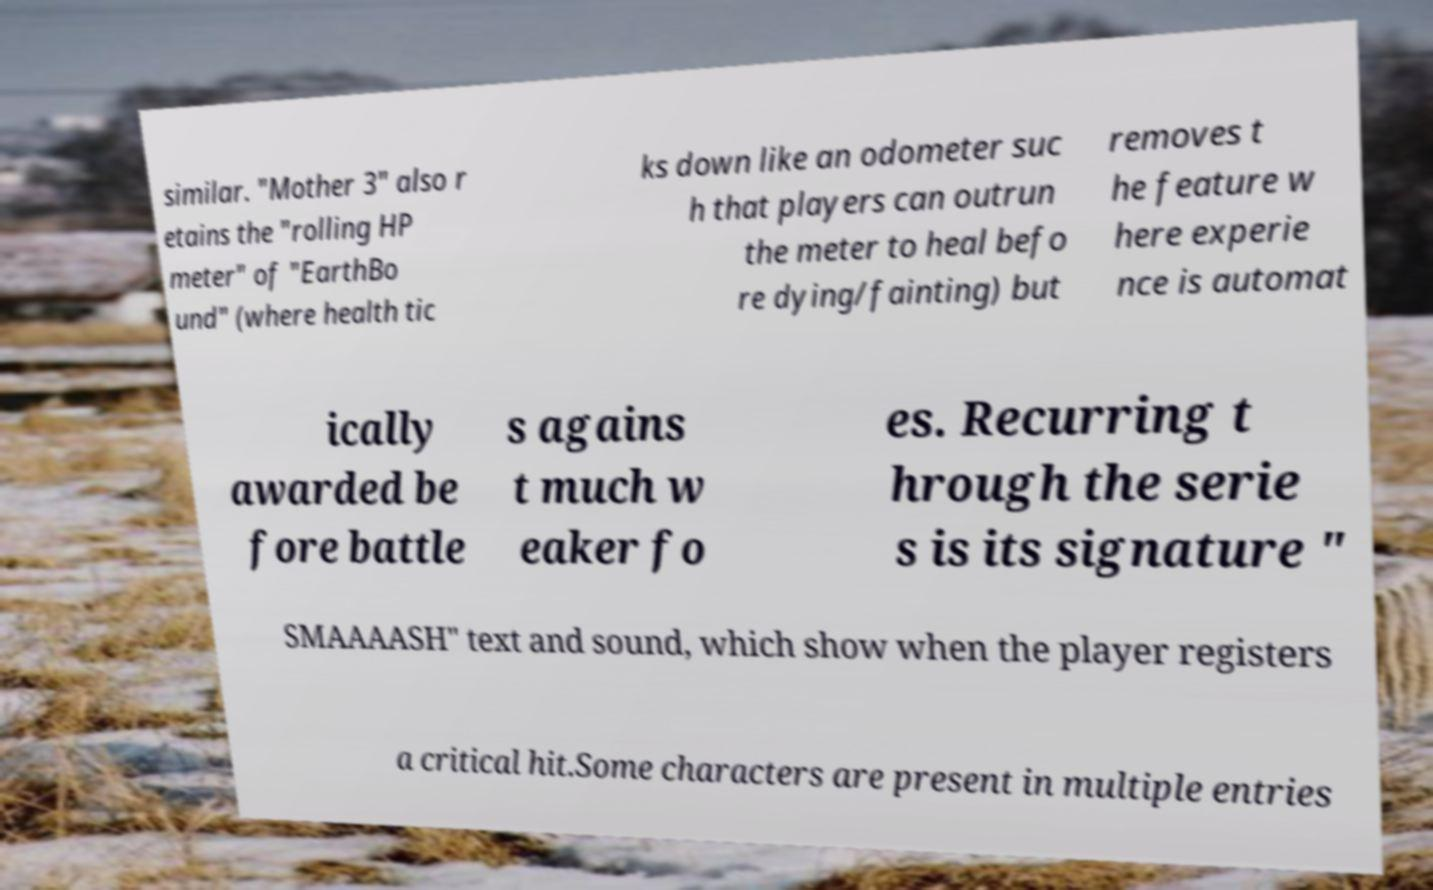Could you extract and type out the text from this image? similar. "Mother 3" also r etains the "rolling HP meter" of "EarthBo und" (where health tic ks down like an odometer suc h that players can outrun the meter to heal befo re dying/fainting) but removes t he feature w here experie nce is automat ically awarded be fore battle s agains t much w eaker fo es. Recurring t hrough the serie s is its signature " SMAAAASH" text and sound, which show when the player registers a critical hit.Some characters are present in multiple entries 